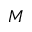Convert formula to latex. <formula><loc_0><loc_0><loc_500><loc_500>M</formula> 